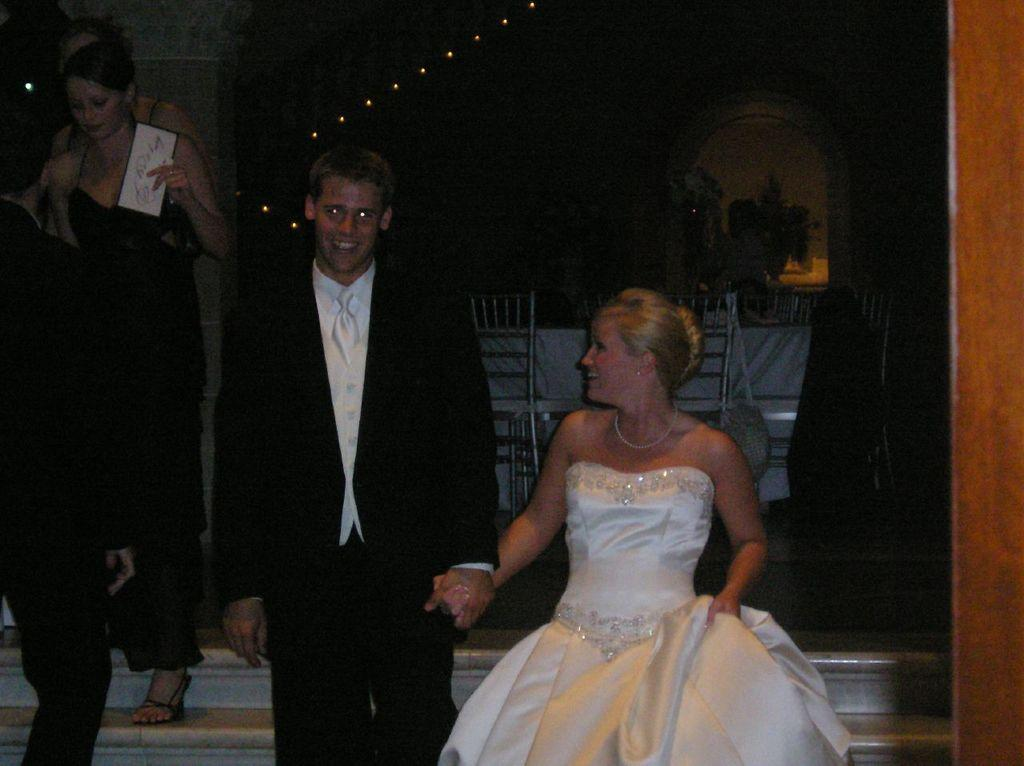What are the persons in the image doing? The persons in the image are getting down from steps. How would you describe the lighting conditions in the image? The background is dark, but there are lights visible in the background. What can be seen in the background of the image? Flower pots and plants are visible in the background. What type of bears can be seen interacting with the yarn in the image? There are no bears or yarn present in the image. 